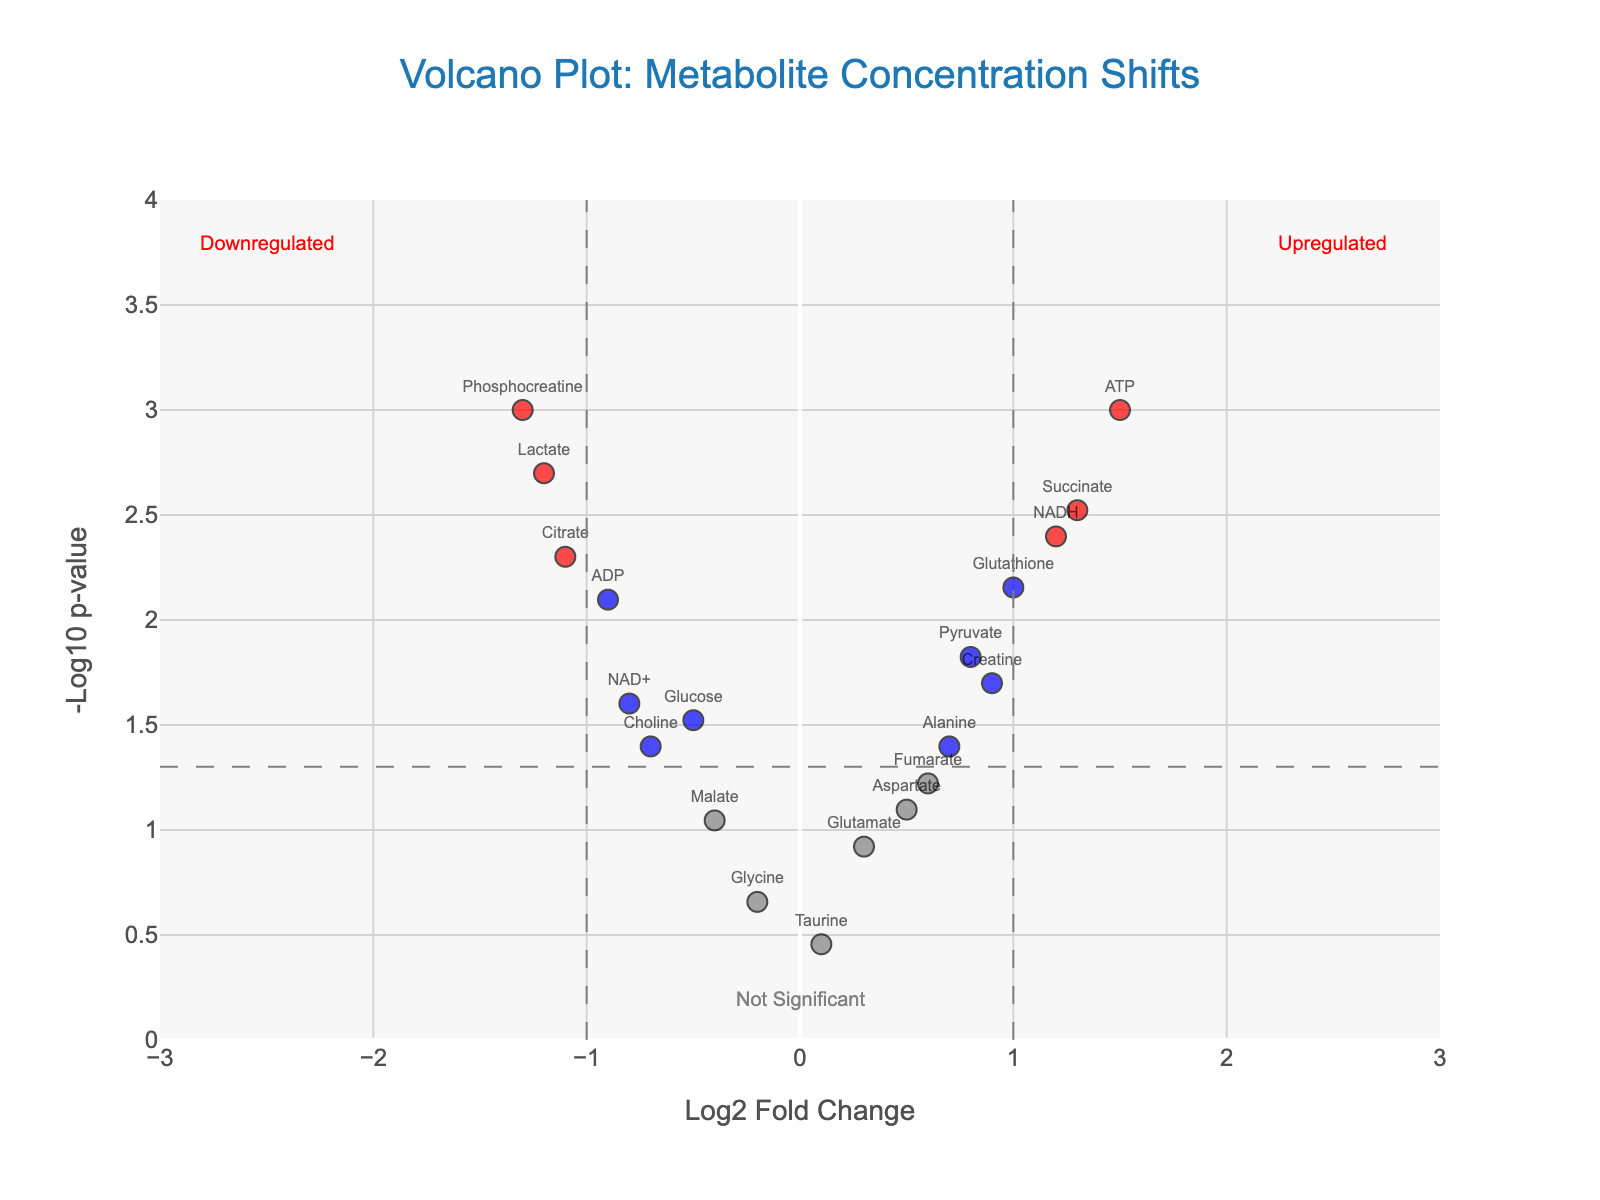Which metabolite has the highest -log10(p-value)? The metabolite with the highest -log10(p-value) will be the one with the highest y-coordinate on the plot. From the figure, this is ATP.
Answer: ATP How many metabolites are marked as significantly upregulated (red dots on the right side)? To find the significantly upregulated metabolites, look for red dots with a positive log2 fold change (right side of the plot). From the figure, these are ATP, Succinate, NADH, and Glutathione.
Answer: 4 Which metabolite has the largest negative log2 fold change? The metabolite with the most negative log2 fold change will have the lowest x-coordinate on the left side of the plot. From the figure, this is Phosphocreatine.
Answer: Phosphocreatine What is the log2 fold change and p-value for the metabolite Creatine? Locate Creatine on the plot and read its x (log2 fold change) and y (-log10 p-value) coordinates, then convert -log10(p-value) back to p-value. From the figure, Creatine has log2 fold change of 0.9 and its p-value is 0.02.
Answer: Log2 FC: 0.9, p-value: 0.02 How many metabolites are shown as not significant (grey dots)? Grey dots represent metabolites not considered significant as they do not meet the significance thresholds. Count all the grey dots in the plot. From the data-names, these are Glutamate, Glycine, Fumarate, Malate, Taurine, and Aspartate.
Answer: 6 What is the significance threshold for -log10(p-value) shown on the plot? The significance threshold for -log10(p-value) can be found on the plot as the dashed grey horizontal line. It represents -log10(0.05) which is approximately 1.3.
Answer: 1.3 Are there more significantly upregulated metabolites or significantly downregulated metabolites? Compare the number of red dots on the right side (upregulated) with the number of red dots on the left side (downregulated). There are 4 significantly upregulated (right) and 4 significantly downregulated (left).
Answer: Equal Which metabolite has a p-value of 0.001 and what is its log2 fold change? Identify the metabolite with y-coordinate corresponding to -log10(0.001). Both ATP and Phosphocreatine meet this criterion. Their log2 fold changes are 1.5 for ATP and -1.3 for Phosphocreatine.
Answer: ATP: 1.5, Phosphocreatine: -1.3 